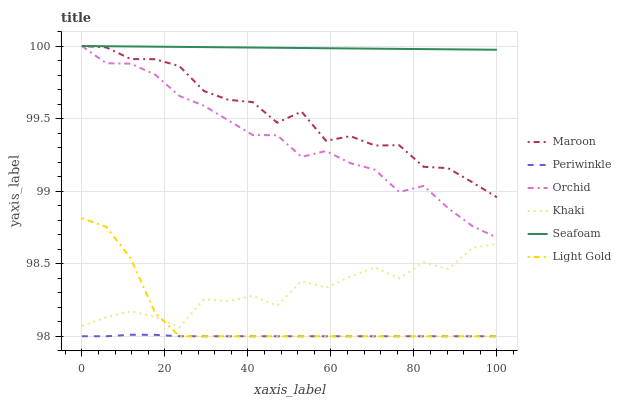Does Maroon have the minimum area under the curve?
Answer yes or no. No. Does Maroon have the maximum area under the curve?
Answer yes or no. No. Is Maroon the smoothest?
Answer yes or no. No. Is Maroon the roughest?
Answer yes or no. No. Does Maroon have the lowest value?
Answer yes or no. No. Does Periwinkle have the highest value?
Answer yes or no. No. Is Periwinkle less than Khaki?
Answer yes or no. Yes. Is Seafoam greater than Periwinkle?
Answer yes or no. Yes. Does Periwinkle intersect Khaki?
Answer yes or no. No. 